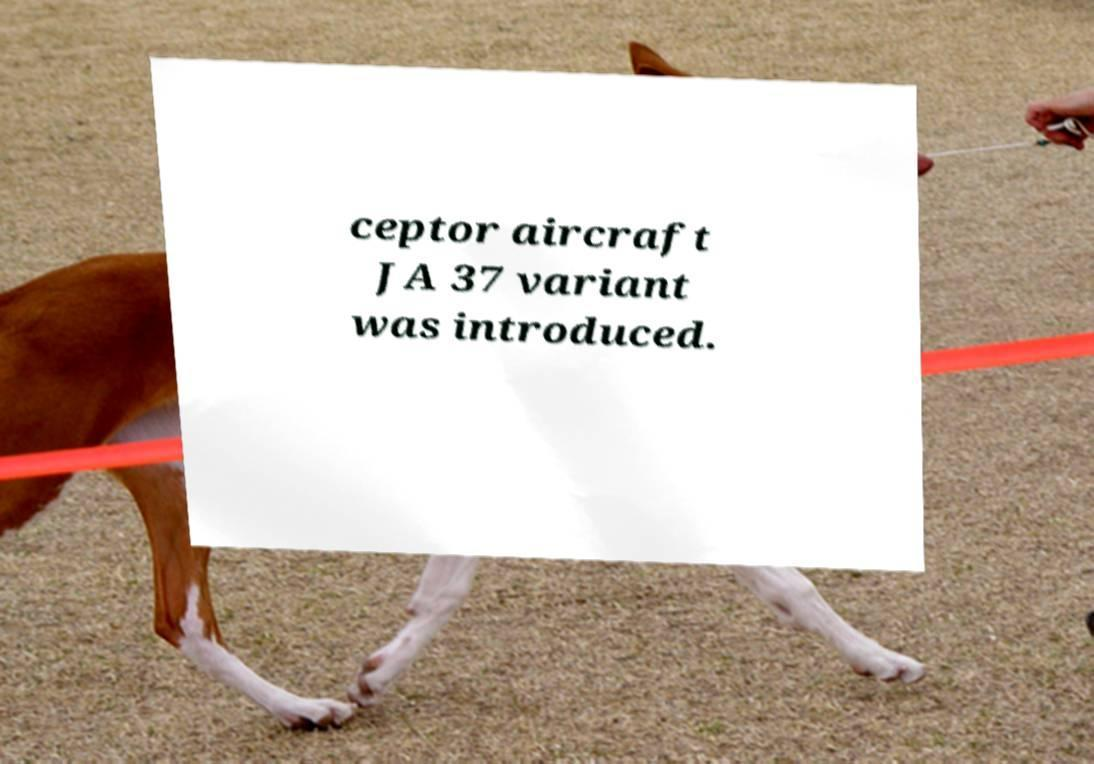Please identify and transcribe the text found in this image. ceptor aircraft JA 37 variant was introduced. 